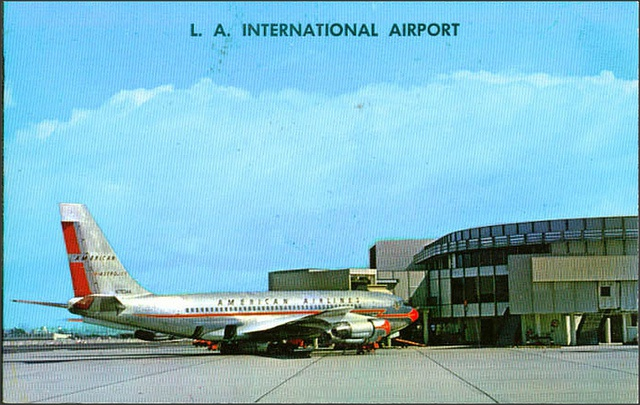Describe the objects in this image and their specific colors. I can see a airplane in black, ivory, darkgray, and gray tones in this image. 